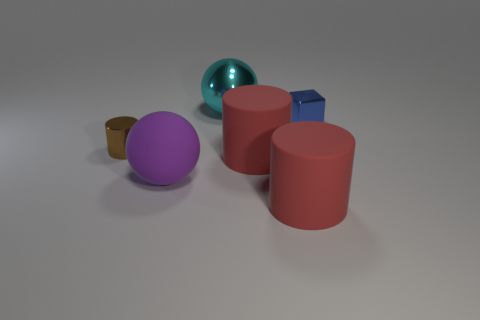Is the number of red objects greater than the number of blue metallic things?
Keep it short and to the point. Yes. There is a purple ball; is its size the same as the cylinder left of the cyan sphere?
Give a very brief answer. No. There is a big thing behind the tiny brown metal object; what color is it?
Give a very brief answer. Cyan. How many gray things are spheres or big matte things?
Your answer should be compact. 0. What color is the big matte ball?
Make the answer very short. Purple. Is there any other thing that has the same material as the big purple thing?
Provide a short and direct response. Yes. Are there fewer tiny metallic cylinders in front of the small cylinder than small blue metallic blocks behind the small cube?
Keep it short and to the point. No. The large thing that is in front of the blue metal object and behind the large purple matte sphere has what shape?
Offer a very short reply. Cylinder. What number of small blue shiny things have the same shape as the cyan object?
Give a very brief answer. 0. There is a block that is made of the same material as the cyan ball; what size is it?
Make the answer very short. Small. 